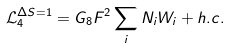<formula> <loc_0><loc_0><loc_500><loc_500>\mathcal { L } _ { 4 } ^ { \Delta S = 1 } = G _ { 8 } F ^ { 2 } \sum _ { i } N _ { i } W _ { i } + h . c .</formula> 